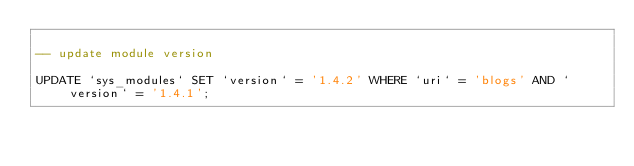Convert code to text. <code><loc_0><loc_0><loc_500><loc_500><_SQL_>
-- update module version

UPDATE `sys_modules` SET `version` = '1.4.2' WHERE `uri` = 'blogs' AND `version` = '1.4.1';

</code> 